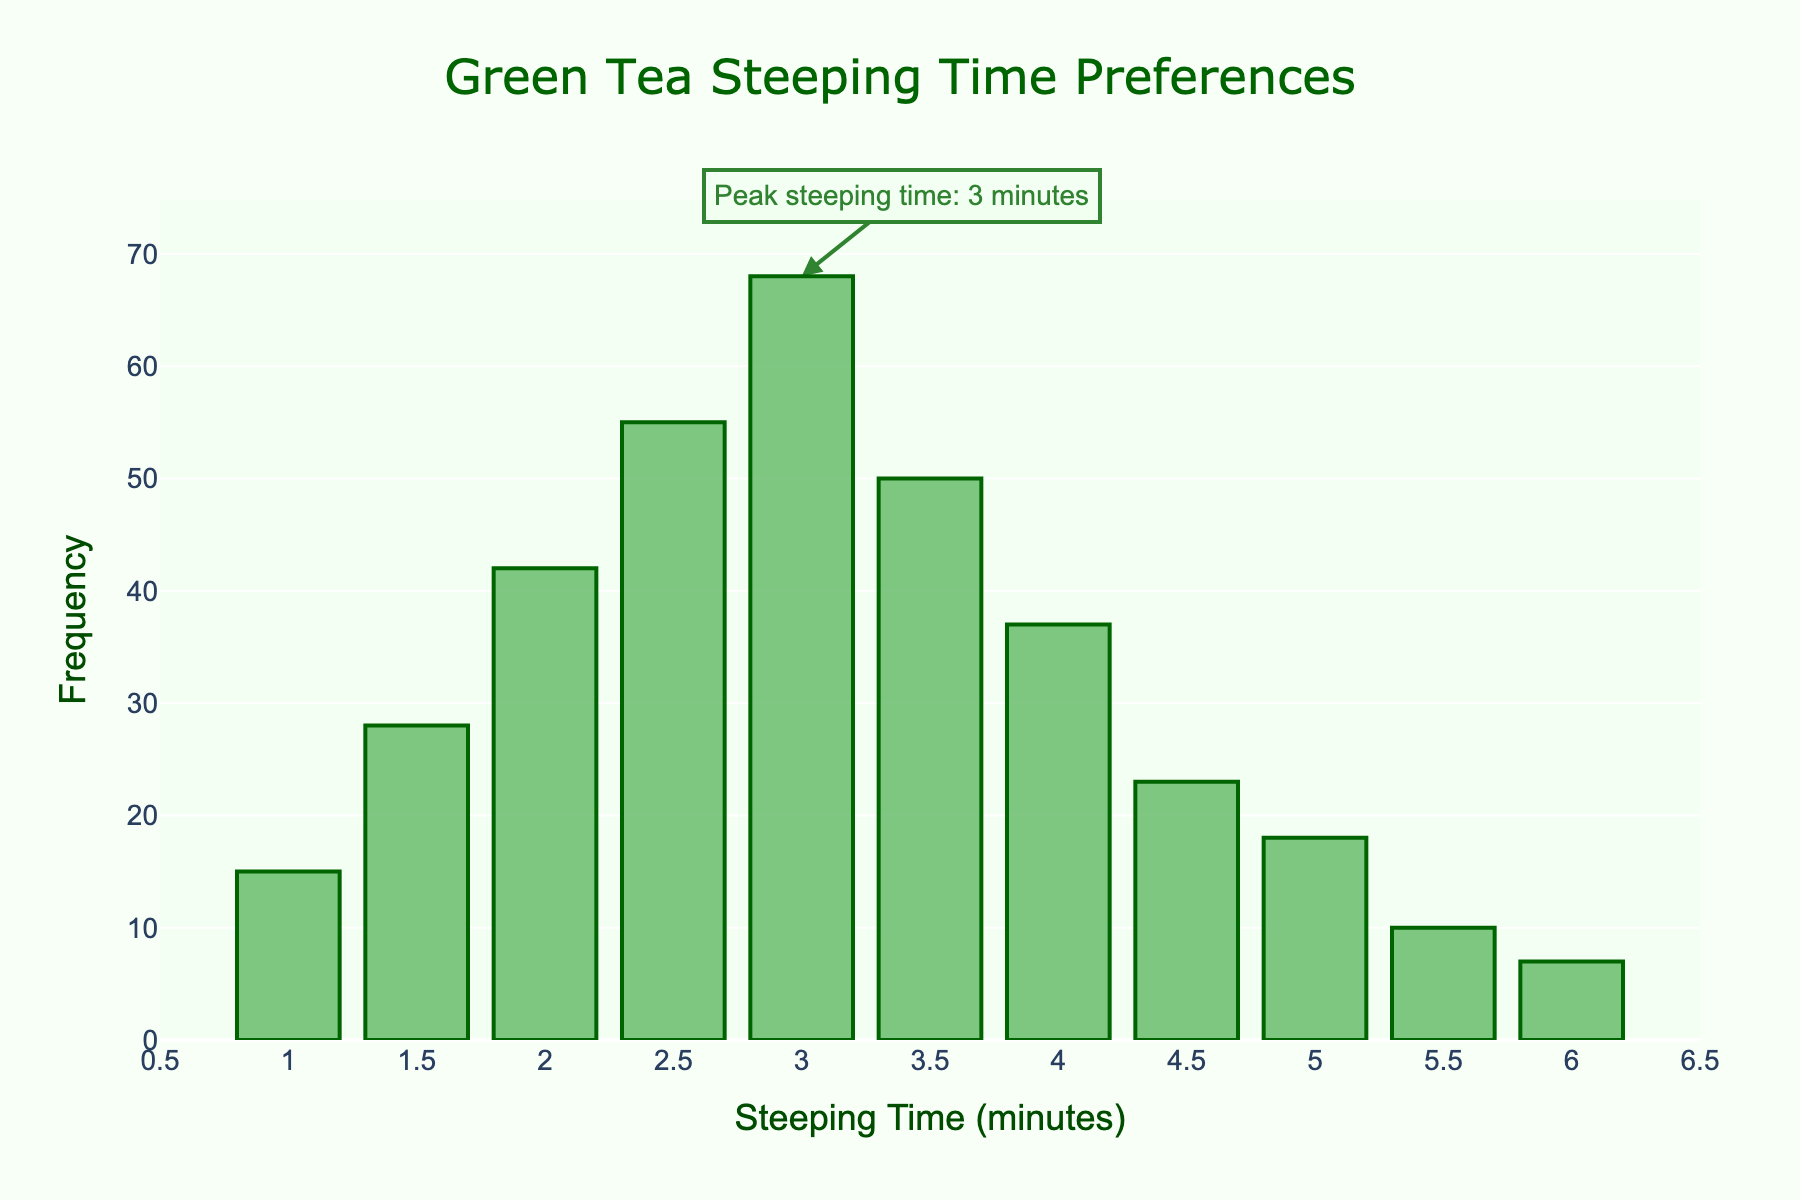What is the title of the plot? The title of the plot is displayed prominently at the top. It can be easily read without needing any interpretation.
Answer: Green Tea Steeping Time Preferences What is the x-axis showing? The x-axis is labeled and shows the steeping time in minutes, as indicated by both the label and the values along the axis.
Answer: Steeping Time (minutes) How many people prefer a steeping time of 3 minutes? Look at the bar corresponding to 3 minutes directly and read the height value from the y-axis or the bar label.
Answer: 68 What is the most preferred steeping time? Compare the heights of all the bars to find the one with the highest value. The tallest bar represents the most preferred steeping time.
Answer: 3 minutes How many total people participated in the survey? Sum the frequency of all the bars to get the total number of participants.
Answer: 353 What percentage of people prefer a steeping time of 2 minutes? Calculate the percentage by dividing the frequency of 2 minutes by the total number of participants and then multiplying by 100.
Answer: Approximately 11.9% What is the difference in frequency between the 2.5 minutes and 3.5 minutes steeping times? Subtract the frequency of the 3.5 minutes steeping time from the frequency of the 2.5 minutes steeping time.
Answer: 5 Which steeping time is preferred by fewer than 10 people? Identify the bars with a frequency below 10 by examining their height and corresponding y-axis values.
Answer: 6 minutes What is the range of steeping times recorded in the survey? Determine the range by subtracting the minimum steeping time from the maximum steeping time shown on the x-axis.
Answer: 5 minutes How does the frequency of the least preferred steeping time compare to the frequency of the most preferred steeping time? Identify the frequencies of both the least and most preferred steeping times and then compare them directly by analyzing the heights of their corresponding bars.
Answer: The least preferred steeping time (6 minutes) has a frequency of 7, while the most preferred steeping time (3 minutes) has a frequency of 68 